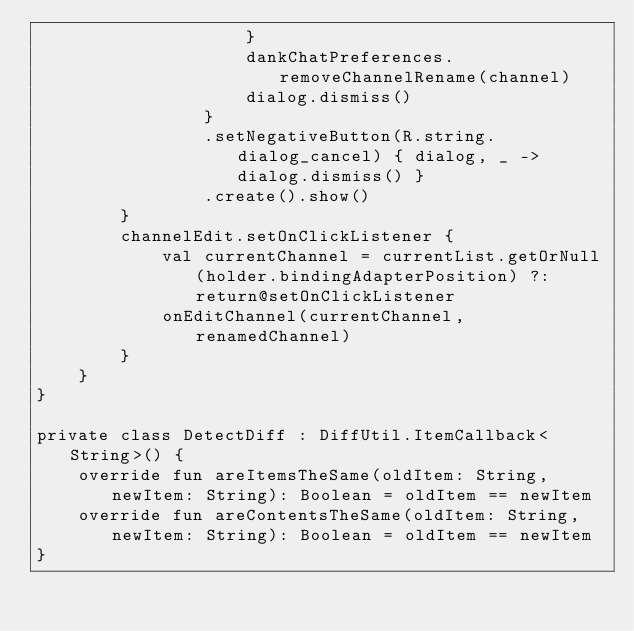<code> <loc_0><loc_0><loc_500><loc_500><_Kotlin_>                    }
                    dankChatPreferences.removeChannelRename(channel)
                    dialog.dismiss()
                }
                .setNegativeButton(R.string.dialog_cancel) { dialog, _ -> dialog.dismiss() }
                .create().show()
        }
        channelEdit.setOnClickListener {
            val currentChannel = currentList.getOrNull(holder.bindingAdapterPosition) ?: return@setOnClickListener
            onEditChannel(currentChannel, renamedChannel)
        }
    }
}

private class DetectDiff : DiffUtil.ItemCallback<String>() {
    override fun areItemsTheSame(oldItem: String, newItem: String): Boolean = oldItem == newItem
    override fun areContentsTheSame(oldItem: String, newItem: String): Boolean = oldItem == newItem
}</code> 